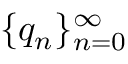<formula> <loc_0><loc_0><loc_500><loc_500>\{ q _ { n } \} _ { n = 0 } ^ { \infty }</formula> 